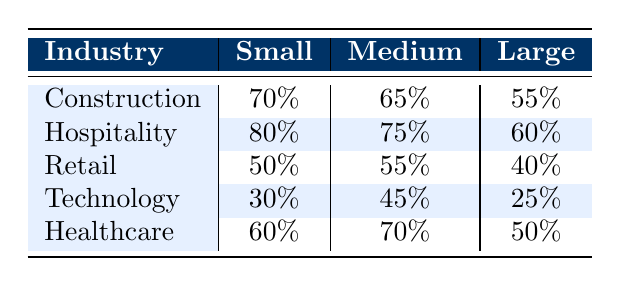What is the willingness to hire formerly incarcerated individuals in the Hospitality industry for small companies? The table shows that the willingness to hire in the Hospitality industry for small companies is 80%.
Answer: 80% Which company size in the Construction industry shows the highest willingness to hire formerly incarcerated individuals? The small company size in the Construction industry shows the highest willingness to hire, at 70%.
Answer: Small Is the willingness to hire lower in large companies compared to medium companies across all industries? In the data, large companies have lower willingness to hire compared to medium companies in Construction (55% vs. 65%), Hospitality (60% vs. 75%), Retail (40% vs. 55%), Technology (25% vs. 45%), and Healthcare (50% vs. 70%), so the statement is true.
Answer: Yes What is the average willingness to hire for small companies across all industries? To find the average, sum the willingness for small companies (70 + 80 + 50 + 30 + 60) = 290 and divide by the number of industries (5), so 290/5 = 58%.
Answer: 58% In which industry does the largest difference in willingness to hire occur between small and large companies? The difference is highest in the Technology industry, where the willingness for small companies is 30% and for large companies is 25%, resulting in a difference of 5%.
Answer: Technology Are medium-sized companies in the Healthcare industry more willing to hire compared to small companies in the Technology industry? The willingness for medium-sized Healthcare companies is 70%, and for small Technology companies, it is 30%, so medium-sized Healthcare companies are indeed more willing to hire.
Answer: Yes What percentage of large companies in the Retail industry is willing to hire formerly incarcerated individuals? The table indicates that 40% of large companies in the Retail industry are willing to hire formerly incarcerated individuals.
Answer: 40% Which industry shows the lowest willingness to hire for medium companies? The Technology industry has the lowest willingness to hire for medium companies at 45%.
Answer: Technology 